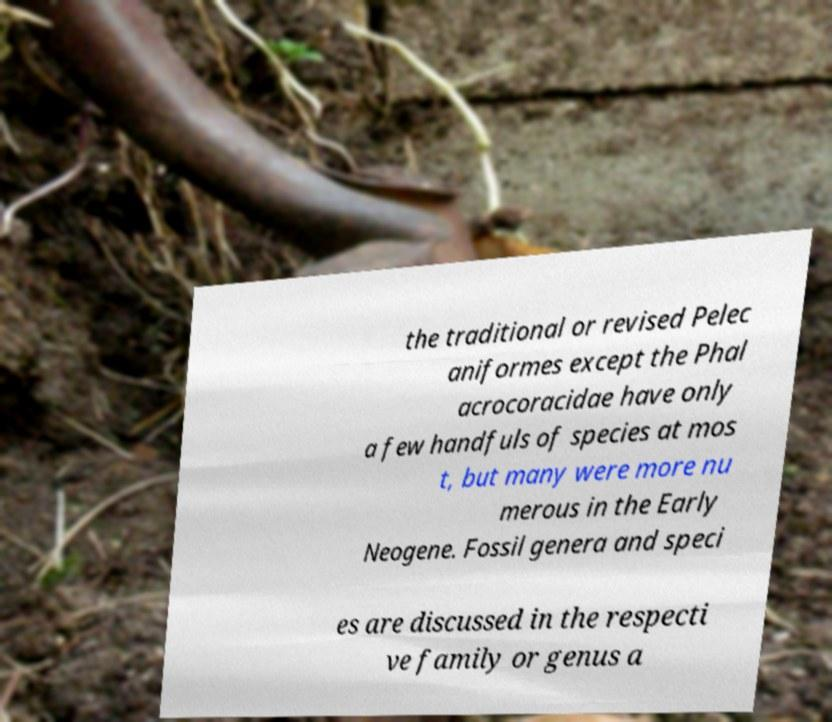Please read and relay the text visible in this image. What does it say? the traditional or revised Pelec aniformes except the Phal acrocoracidae have only a few handfuls of species at mos t, but many were more nu merous in the Early Neogene. Fossil genera and speci es are discussed in the respecti ve family or genus a 